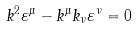Convert formula to latex. <formula><loc_0><loc_0><loc_500><loc_500>k ^ { 2 } \varepsilon ^ { \mu } - k ^ { \mu } k _ { \nu } \varepsilon ^ { \nu } = 0</formula> 